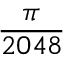Convert formula to latex. <formula><loc_0><loc_0><loc_500><loc_500>\frac { \pi } { 2 0 4 8 }</formula> 